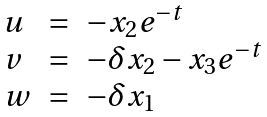Convert formula to latex. <formula><loc_0><loc_0><loc_500><loc_500>\begin{array} { l l l } u & = & - x _ { 2 } e ^ { - t } \\ v & = & - \delta x _ { 2 } - x _ { 3 } e ^ { - t } \\ w & = & - \delta x _ { 1 } \\ \end{array}</formula> 